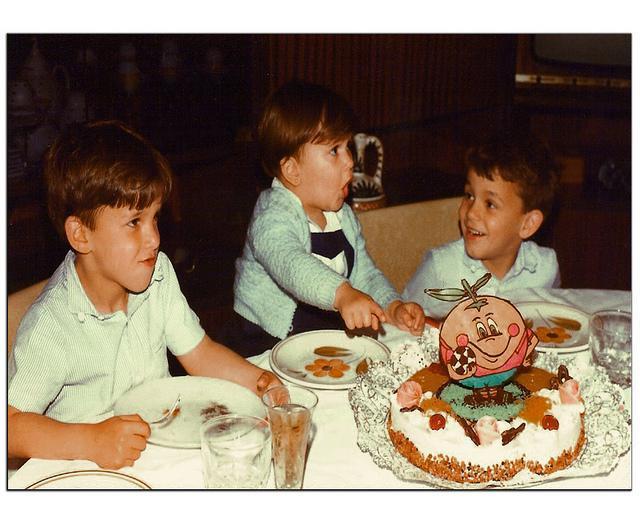How many children are in the picture?
Give a very brief answer. 3. How many cups are visible?
Give a very brief answer. 3. How many people are visible?
Give a very brief answer. 3. How many carrots are on top of the cartoon image?
Give a very brief answer. 0. 